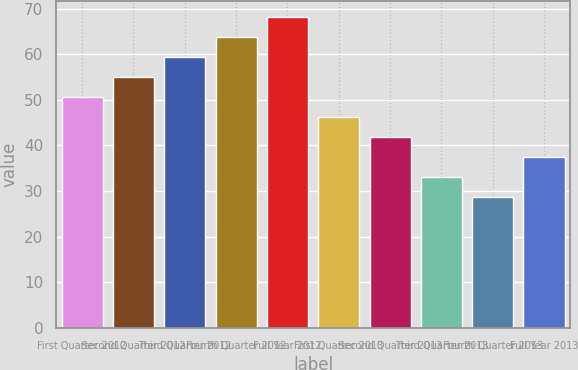Convert chart. <chart><loc_0><loc_0><loc_500><loc_500><bar_chart><fcel>First Quarter 2012<fcel>Second Quarter 2012<fcel>Third Quarter 2012<fcel>Fourth Quarter 2012<fcel>Full Year 2012<fcel>First Quarter 2013<fcel>Second Quarter 2013<fcel>Third Quarter 2013<fcel>Fourth Quarter 2013<fcel>Full Year 2013<nl><fcel>50.6<fcel>55<fcel>59.4<fcel>63.8<fcel>68.2<fcel>46.2<fcel>41.8<fcel>33<fcel>28.6<fcel>37.4<nl></chart> 